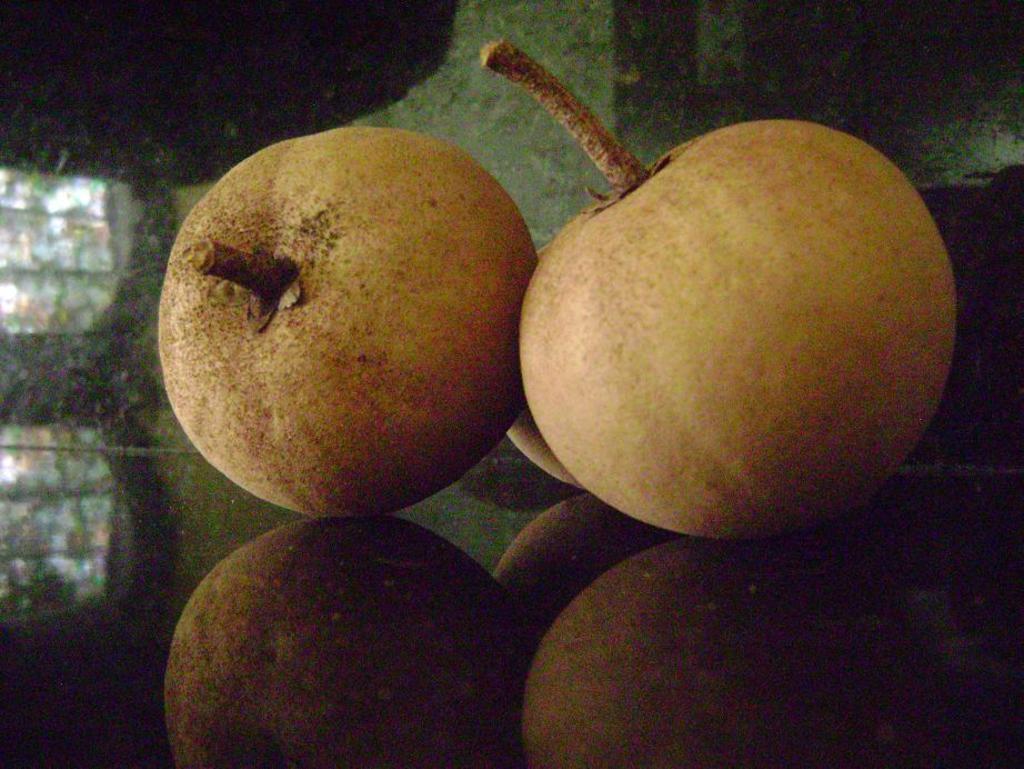In one or two sentences, can you explain what this image depicts? In the image we can see three fruits kept on the surface and we can see reflection of the fruits on the surface. 